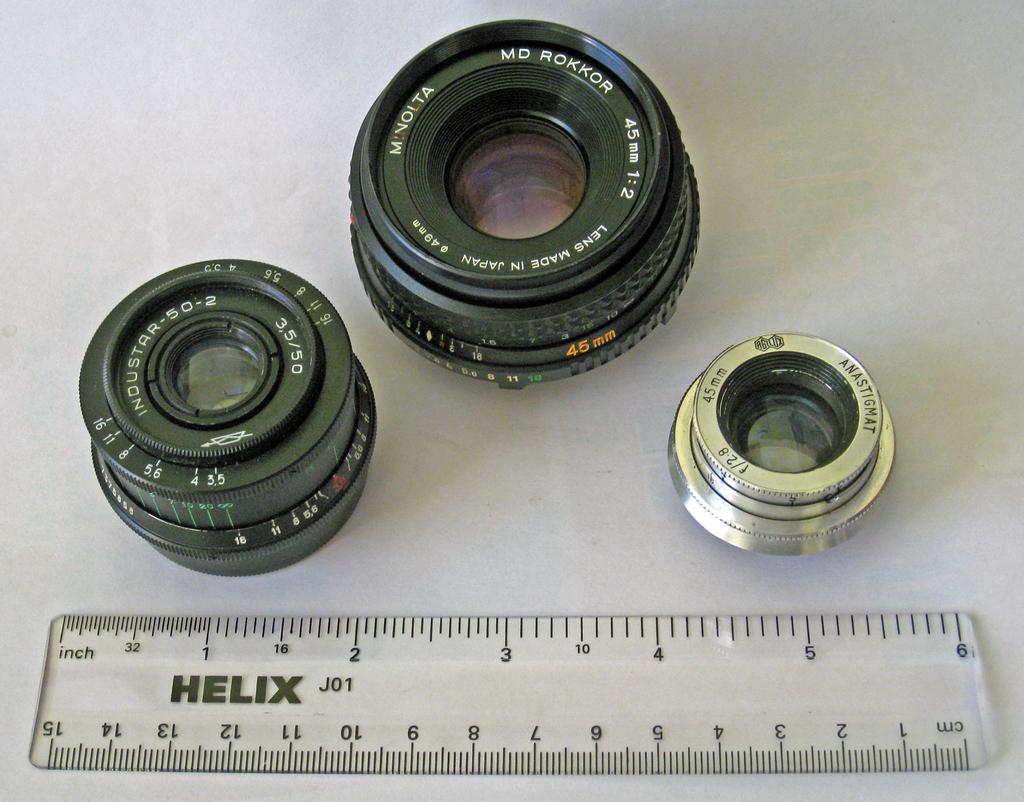What is the name on the ruller?
Provide a short and direct response. Helix. What is the brand of the ruler?
Provide a short and direct response. Helix. 